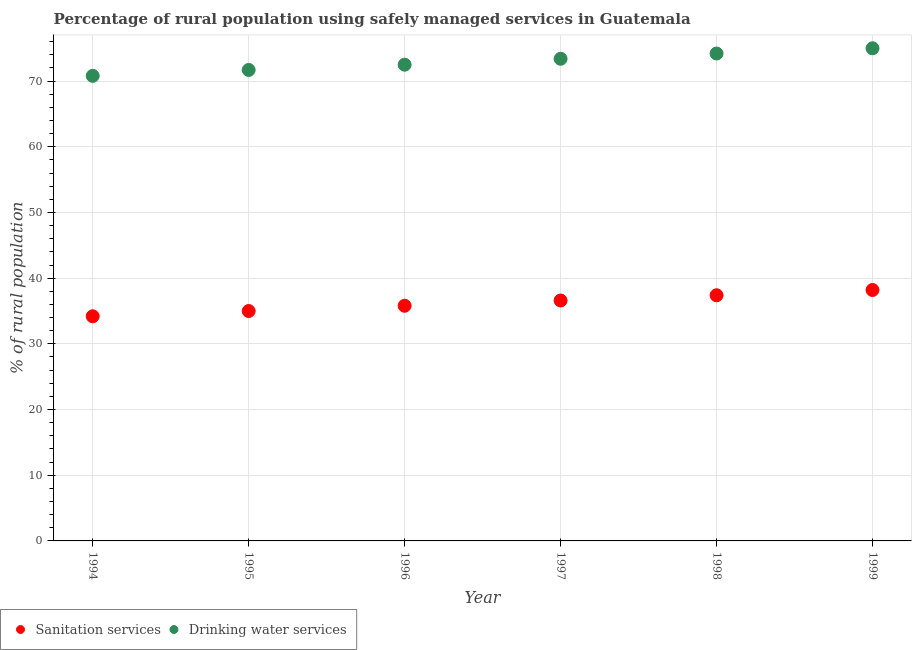How many different coloured dotlines are there?
Your answer should be compact. 2. What is the percentage of rural population who used drinking water services in 1994?
Your response must be concise. 70.8. Across all years, what is the maximum percentage of rural population who used drinking water services?
Your answer should be compact. 75. Across all years, what is the minimum percentage of rural population who used sanitation services?
Offer a very short reply. 34.2. In which year was the percentage of rural population who used sanitation services maximum?
Keep it short and to the point. 1999. What is the total percentage of rural population who used drinking water services in the graph?
Your answer should be compact. 437.6. What is the difference between the percentage of rural population who used sanitation services in 1994 and that in 1998?
Your answer should be compact. -3.2. What is the difference between the percentage of rural population who used sanitation services in 1999 and the percentage of rural population who used drinking water services in 1998?
Give a very brief answer. -36. What is the average percentage of rural population who used sanitation services per year?
Ensure brevity in your answer.  36.2. In the year 1994, what is the difference between the percentage of rural population who used drinking water services and percentage of rural population who used sanitation services?
Give a very brief answer. 36.6. What is the ratio of the percentage of rural population who used drinking water services in 1994 to that in 1995?
Your answer should be compact. 0.99. What is the difference between the highest and the second highest percentage of rural population who used drinking water services?
Offer a very short reply. 0.8. Is the percentage of rural population who used sanitation services strictly greater than the percentage of rural population who used drinking water services over the years?
Give a very brief answer. No. What is the difference between two consecutive major ticks on the Y-axis?
Your answer should be very brief. 10. Are the values on the major ticks of Y-axis written in scientific E-notation?
Your answer should be compact. No. Does the graph contain any zero values?
Ensure brevity in your answer.  No. Does the graph contain grids?
Your response must be concise. Yes. Where does the legend appear in the graph?
Keep it short and to the point. Bottom left. How many legend labels are there?
Make the answer very short. 2. What is the title of the graph?
Ensure brevity in your answer.  Percentage of rural population using safely managed services in Guatemala. What is the label or title of the X-axis?
Keep it short and to the point. Year. What is the label or title of the Y-axis?
Your answer should be very brief. % of rural population. What is the % of rural population in Sanitation services in 1994?
Keep it short and to the point. 34.2. What is the % of rural population in Drinking water services in 1994?
Ensure brevity in your answer.  70.8. What is the % of rural population in Drinking water services in 1995?
Provide a succinct answer. 71.7. What is the % of rural population of Sanitation services in 1996?
Keep it short and to the point. 35.8. What is the % of rural population in Drinking water services in 1996?
Offer a very short reply. 72.5. What is the % of rural population of Sanitation services in 1997?
Provide a succinct answer. 36.6. What is the % of rural population of Drinking water services in 1997?
Your answer should be compact. 73.4. What is the % of rural population in Sanitation services in 1998?
Offer a terse response. 37.4. What is the % of rural population in Drinking water services in 1998?
Offer a terse response. 74.2. What is the % of rural population in Sanitation services in 1999?
Keep it short and to the point. 38.2. What is the % of rural population in Drinking water services in 1999?
Ensure brevity in your answer.  75. Across all years, what is the maximum % of rural population of Sanitation services?
Provide a succinct answer. 38.2. Across all years, what is the maximum % of rural population of Drinking water services?
Your answer should be very brief. 75. Across all years, what is the minimum % of rural population in Sanitation services?
Provide a short and direct response. 34.2. Across all years, what is the minimum % of rural population of Drinking water services?
Ensure brevity in your answer.  70.8. What is the total % of rural population of Sanitation services in the graph?
Make the answer very short. 217.2. What is the total % of rural population in Drinking water services in the graph?
Provide a succinct answer. 437.6. What is the difference between the % of rural population in Drinking water services in 1994 and that in 1995?
Your answer should be compact. -0.9. What is the difference between the % of rural population of Sanitation services in 1994 and that in 1996?
Your answer should be very brief. -1.6. What is the difference between the % of rural population of Drinking water services in 1994 and that in 1999?
Your answer should be compact. -4.2. What is the difference between the % of rural population in Drinking water services in 1995 and that in 1997?
Keep it short and to the point. -1.7. What is the difference between the % of rural population of Sanitation services in 1995 and that in 1998?
Make the answer very short. -2.4. What is the difference between the % of rural population in Sanitation services in 1995 and that in 1999?
Provide a short and direct response. -3.2. What is the difference between the % of rural population in Sanitation services in 1996 and that in 1997?
Your answer should be compact. -0.8. What is the difference between the % of rural population of Drinking water services in 1996 and that in 1997?
Your response must be concise. -0.9. What is the difference between the % of rural population of Drinking water services in 1996 and that in 1998?
Your answer should be compact. -1.7. What is the difference between the % of rural population in Drinking water services in 1997 and that in 1999?
Make the answer very short. -1.6. What is the difference between the % of rural population in Sanitation services in 1998 and that in 1999?
Your answer should be compact. -0.8. What is the difference between the % of rural population in Sanitation services in 1994 and the % of rural population in Drinking water services in 1995?
Offer a very short reply. -37.5. What is the difference between the % of rural population in Sanitation services in 1994 and the % of rural population in Drinking water services in 1996?
Ensure brevity in your answer.  -38.3. What is the difference between the % of rural population of Sanitation services in 1994 and the % of rural population of Drinking water services in 1997?
Give a very brief answer. -39.2. What is the difference between the % of rural population in Sanitation services in 1994 and the % of rural population in Drinking water services in 1999?
Provide a succinct answer. -40.8. What is the difference between the % of rural population of Sanitation services in 1995 and the % of rural population of Drinking water services in 1996?
Ensure brevity in your answer.  -37.5. What is the difference between the % of rural population of Sanitation services in 1995 and the % of rural population of Drinking water services in 1997?
Make the answer very short. -38.4. What is the difference between the % of rural population in Sanitation services in 1995 and the % of rural population in Drinking water services in 1998?
Your answer should be very brief. -39.2. What is the difference between the % of rural population in Sanitation services in 1996 and the % of rural population in Drinking water services in 1997?
Offer a terse response. -37.6. What is the difference between the % of rural population of Sanitation services in 1996 and the % of rural population of Drinking water services in 1998?
Your answer should be compact. -38.4. What is the difference between the % of rural population of Sanitation services in 1996 and the % of rural population of Drinking water services in 1999?
Your response must be concise. -39.2. What is the difference between the % of rural population of Sanitation services in 1997 and the % of rural population of Drinking water services in 1998?
Provide a short and direct response. -37.6. What is the difference between the % of rural population of Sanitation services in 1997 and the % of rural population of Drinking water services in 1999?
Provide a succinct answer. -38.4. What is the difference between the % of rural population of Sanitation services in 1998 and the % of rural population of Drinking water services in 1999?
Make the answer very short. -37.6. What is the average % of rural population of Sanitation services per year?
Offer a very short reply. 36.2. What is the average % of rural population of Drinking water services per year?
Your answer should be very brief. 72.93. In the year 1994, what is the difference between the % of rural population of Sanitation services and % of rural population of Drinking water services?
Offer a terse response. -36.6. In the year 1995, what is the difference between the % of rural population in Sanitation services and % of rural population in Drinking water services?
Provide a succinct answer. -36.7. In the year 1996, what is the difference between the % of rural population in Sanitation services and % of rural population in Drinking water services?
Offer a terse response. -36.7. In the year 1997, what is the difference between the % of rural population in Sanitation services and % of rural population in Drinking water services?
Ensure brevity in your answer.  -36.8. In the year 1998, what is the difference between the % of rural population of Sanitation services and % of rural population of Drinking water services?
Keep it short and to the point. -36.8. In the year 1999, what is the difference between the % of rural population of Sanitation services and % of rural population of Drinking water services?
Your answer should be compact. -36.8. What is the ratio of the % of rural population of Sanitation services in 1994 to that in 1995?
Provide a succinct answer. 0.98. What is the ratio of the % of rural population in Drinking water services in 1994 to that in 1995?
Offer a very short reply. 0.99. What is the ratio of the % of rural population in Sanitation services in 1994 to that in 1996?
Your response must be concise. 0.96. What is the ratio of the % of rural population in Drinking water services in 1994 to that in 1996?
Give a very brief answer. 0.98. What is the ratio of the % of rural population in Sanitation services in 1994 to that in 1997?
Your answer should be compact. 0.93. What is the ratio of the % of rural population in Drinking water services in 1994 to that in 1997?
Provide a succinct answer. 0.96. What is the ratio of the % of rural population in Sanitation services in 1994 to that in 1998?
Offer a terse response. 0.91. What is the ratio of the % of rural population in Drinking water services in 1994 to that in 1998?
Ensure brevity in your answer.  0.95. What is the ratio of the % of rural population of Sanitation services in 1994 to that in 1999?
Your response must be concise. 0.9. What is the ratio of the % of rural population of Drinking water services in 1994 to that in 1999?
Your answer should be very brief. 0.94. What is the ratio of the % of rural population in Sanitation services in 1995 to that in 1996?
Your response must be concise. 0.98. What is the ratio of the % of rural population in Drinking water services in 1995 to that in 1996?
Your response must be concise. 0.99. What is the ratio of the % of rural population in Sanitation services in 1995 to that in 1997?
Offer a terse response. 0.96. What is the ratio of the % of rural population in Drinking water services in 1995 to that in 1997?
Provide a succinct answer. 0.98. What is the ratio of the % of rural population in Sanitation services in 1995 to that in 1998?
Keep it short and to the point. 0.94. What is the ratio of the % of rural population of Drinking water services in 1995 to that in 1998?
Ensure brevity in your answer.  0.97. What is the ratio of the % of rural population of Sanitation services in 1995 to that in 1999?
Your answer should be very brief. 0.92. What is the ratio of the % of rural population in Drinking water services in 1995 to that in 1999?
Your answer should be compact. 0.96. What is the ratio of the % of rural population of Sanitation services in 1996 to that in 1997?
Provide a short and direct response. 0.98. What is the ratio of the % of rural population in Drinking water services in 1996 to that in 1997?
Provide a succinct answer. 0.99. What is the ratio of the % of rural population of Sanitation services in 1996 to that in 1998?
Provide a short and direct response. 0.96. What is the ratio of the % of rural population of Drinking water services in 1996 to that in 1998?
Offer a very short reply. 0.98. What is the ratio of the % of rural population of Sanitation services in 1996 to that in 1999?
Keep it short and to the point. 0.94. What is the ratio of the % of rural population of Drinking water services in 1996 to that in 1999?
Provide a short and direct response. 0.97. What is the ratio of the % of rural population of Sanitation services in 1997 to that in 1998?
Your response must be concise. 0.98. What is the ratio of the % of rural population in Sanitation services in 1997 to that in 1999?
Give a very brief answer. 0.96. What is the ratio of the % of rural population in Drinking water services in 1997 to that in 1999?
Make the answer very short. 0.98. What is the ratio of the % of rural population in Sanitation services in 1998 to that in 1999?
Give a very brief answer. 0.98. What is the ratio of the % of rural population in Drinking water services in 1998 to that in 1999?
Make the answer very short. 0.99. What is the difference between the highest and the second highest % of rural population in Sanitation services?
Provide a succinct answer. 0.8. What is the difference between the highest and the lowest % of rural population in Sanitation services?
Your answer should be very brief. 4. 